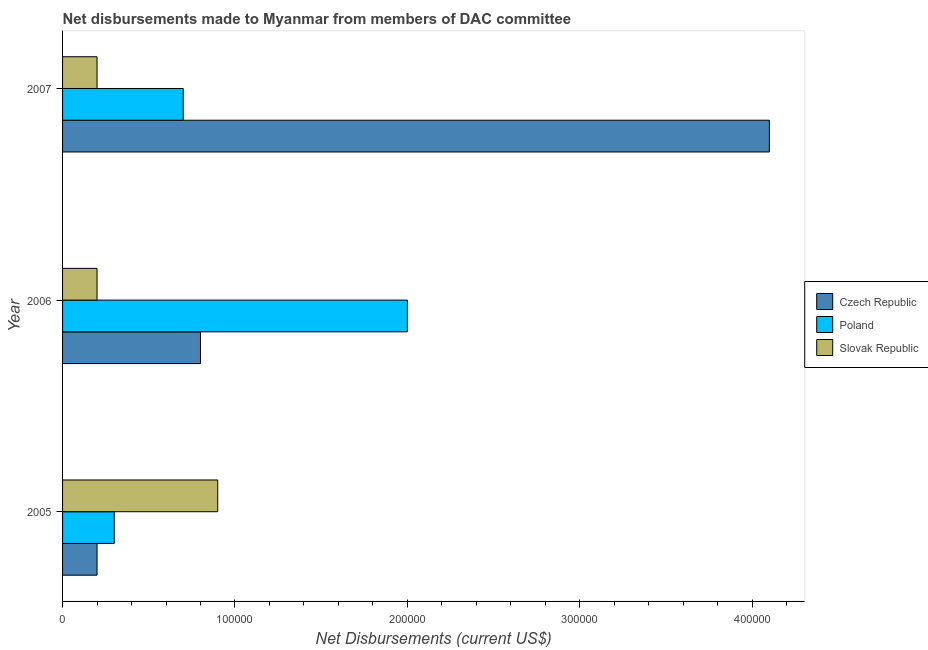How many different coloured bars are there?
Offer a very short reply. 3. How many groups of bars are there?
Your answer should be very brief. 3. Are the number of bars on each tick of the Y-axis equal?
Ensure brevity in your answer.  Yes. How many bars are there on the 1st tick from the top?
Provide a short and direct response. 3. What is the label of the 1st group of bars from the top?
Your answer should be very brief. 2007. In how many cases, is the number of bars for a given year not equal to the number of legend labels?
Your answer should be very brief. 0. What is the net disbursements made by czech republic in 2005?
Provide a short and direct response. 2.00e+04. Across all years, what is the maximum net disbursements made by poland?
Provide a short and direct response. 2.00e+05. Across all years, what is the minimum net disbursements made by slovak republic?
Give a very brief answer. 2.00e+04. In which year was the net disbursements made by poland maximum?
Your answer should be compact. 2006. What is the total net disbursements made by czech republic in the graph?
Give a very brief answer. 5.10e+05. What is the difference between the net disbursements made by poland in 2005 and that in 2006?
Your response must be concise. -1.70e+05. What is the difference between the net disbursements made by slovak republic in 2007 and the net disbursements made by poland in 2005?
Your answer should be compact. -10000. What is the average net disbursements made by poland per year?
Provide a succinct answer. 1.00e+05. In the year 2006, what is the difference between the net disbursements made by czech republic and net disbursements made by slovak republic?
Offer a terse response. 6.00e+04. In how many years, is the net disbursements made by poland greater than 220000 US$?
Offer a very short reply. 0. Is the net disbursements made by poland in 2006 less than that in 2007?
Keep it short and to the point. No. Is the difference between the net disbursements made by poland in 2006 and 2007 greater than the difference between the net disbursements made by czech republic in 2006 and 2007?
Your response must be concise. Yes. What is the difference between the highest and the second highest net disbursements made by czech republic?
Your answer should be compact. 3.30e+05. What is the difference between the highest and the lowest net disbursements made by czech republic?
Provide a succinct answer. 3.90e+05. Is the sum of the net disbursements made by czech republic in 2005 and 2006 greater than the maximum net disbursements made by slovak republic across all years?
Make the answer very short. Yes. What does the 2nd bar from the top in 2006 represents?
Provide a succinct answer. Poland. What does the 3rd bar from the bottom in 2006 represents?
Offer a very short reply. Slovak Republic. Is it the case that in every year, the sum of the net disbursements made by czech republic and net disbursements made by poland is greater than the net disbursements made by slovak republic?
Your answer should be compact. No. How many bars are there?
Your answer should be very brief. 9. How many years are there in the graph?
Your answer should be compact. 3. What is the difference between two consecutive major ticks on the X-axis?
Your answer should be compact. 1.00e+05. Does the graph contain any zero values?
Provide a short and direct response. No. Where does the legend appear in the graph?
Provide a short and direct response. Center right. What is the title of the graph?
Keep it short and to the point. Net disbursements made to Myanmar from members of DAC committee. Does "Liquid fuel" appear as one of the legend labels in the graph?
Provide a succinct answer. No. What is the label or title of the X-axis?
Offer a very short reply. Net Disbursements (current US$). What is the label or title of the Y-axis?
Your answer should be very brief. Year. What is the Net Disbursements (current US$) of Poland in 2006?
Provide a succinct answer. 2.00e+05. What is the Net Disbursements (current US$) of Slovak Republic in 2006?
Your response must be concise. 2.00e+04. What is the Net Disbursements (current US$) of Slovak Republic in 2007?
Give a very brief answer. 2.00e+04. Across all years, what is the maximum Net Disbursements (current US$) in Slovak Republic?
Provide a short and direct response. 9.00e+04. Across all years, what is the minimum Net Disbursements (current US$) in Czech Republic?
Your answer should be very brief. 2.00e+04. Across all years, what is the minimum Net Disbursements (current US$) of Poland?
Provide a short and direct response. 3.00e+04. Across all years, what is the minimum Net Disbursements (current US$) of Slovak Republic?
Your answer should be very brief. 2.00e+04. What is the total Net Disbursements (current US$) of Czech Republic in the graph?
Offer a very short reply. 5.10e+05. What is the total Net Disbursements (current US$) in Poland in the graph?
Offer a terse response. 3.00e+05. What is the difference between the Net Disbursements (current US$) in Czech Republic in 2005 and that in 2007?
Provide a short and direct response. -3.90e+05. What is the difference between the Net Disbursements (current US$) in Poland in 2005 and that in 2007?
Your answer should be compact. -4.00e+04. What is the difference between the Net Disbursements (current US$) of Czech Republic in 2006 and that in 2007?
Provide a succinct answer. -3.30e+05. What is the difference between the Net Disbursements (current US$) of Slovak Republic in 2006 and that in 2007?
Keep it short and to the point. 0. What is the difference between the Net Disbursements (current US$) of Czech Republic in 2005 and the Net Disbursements (current US$) of Poland in 2006?
Your answer should be compact. -1.80e+05. What is the difference between the Net Disbursements (current US$) of Poland in 2005 and the Net Disbursements (current US$) of Slovak Republic in 2006?
Provide a succinct answer. 10000. What is the difference between the Net Disbursements (current US$) in Czech Republic in 2005 and the Net Disbursements (current US$) in Slovak Republic in 2007?
Ensure brevity in your answer.  0. What is the difference between the Net Disbursements (current US$) in Poland in 2005 and the Net Disbursements (current US$) in Slovak Republic in 2007?
Provide a short and direct response. 10000. What is the difference between the Net Disbursements (current US$) of Czech Republic in 2006 and the Net Disbursements (current US$) of Poland in 2007?
Your response must be concise. 10000. What is the difference between the Net Disbursements (current US$) of Czech Republic in 2006 and the Net Disbursements (current US$) of Slovak Republic in 2007?
Offer a terse response. 6.00e+04. What is the average Net Disbursements (current US$) of Slovak Republic per year?
Offer a very short reply. 4.33e+04. In the year 2006, what is the difference between the Net Disbursements (current US$) in Czech Republic and Net Disbursements (current US$) in Poland?
Ensure brevity in your answer.  -1.20e+05. In the year 2006, what is the difference between the Net Disbursements (current US$) in Czech Republic and Net Disbursements (current US$) in Slovak Republic?
Provide a short and direct response. 6.00e+04. In the year 2006, what is the difference between the Net Disbursements (current US$) in Poland and Net Disbursements (current US$) in Slovak Republic?
Provide a short and direct response. 1.80e+05. In the year 2007, what is the difference between the Net Disbursements (current US$) in Poland and Net Disbursements (current US$) in Slovak Republic?
Provide a short and direct response. 5.00e+04. What is the ratio of the Net Disbursements (current US$) of Czech Republic in 2005 to that in 2006?
Provide a succinct answer. 0.25. What is the ratio of the Net Disbursements (current US$) of Poland in 2005 to that in 2006?
Keep it short and to the point. 0.15. What is the ratio of the Net Disbursements (current US$) in Slovak Republic in 2005 to that in 2006?
Provide a short and direct response. 4.5. What is the ratio of the Net Disbursements (current US$) of Czech Republic in 2005 to that in 2007?
Offer a terse response. 0.05. What is the ratio of the Net Disbursements (current US$) of Poland in 2005 to that in 2007?
Give a very brief answer. 0.43. What is the ratio of the Net Disbursements (current US$) in Slovak Republic in 2005 to that in 2007?
Ensure brevity in your answer.  4.5. What is the ratio of the Net Disbursements (current US$) in Czech Republic in 2006 to that in 2007?
Your answer should be compact. 0.2. What is the ratio of the Net Disbursements (current US$) of Poland in 2006 to that in 2007?
Give a very brief answer. 2.86. What is the difference between the highest and the second highest Net Disbursements (current US$) of Poland?
Provide a succinct answer. 1.30e+05. What is the difference between the highest and the second highest Net Disbursements (current US$) of Slovak Republic?
Provide a succinct answer. 7.00e+04. What is the difference between the highest and the lowest Net Disbursements (current US$) of Czech Republic?
Keep it short and to the point. 3.90e+05. What is the difference between the highest and the lowest Net Disbursements (current US$) in Poland?
Provide a succinct answer. 1.70e+05. 